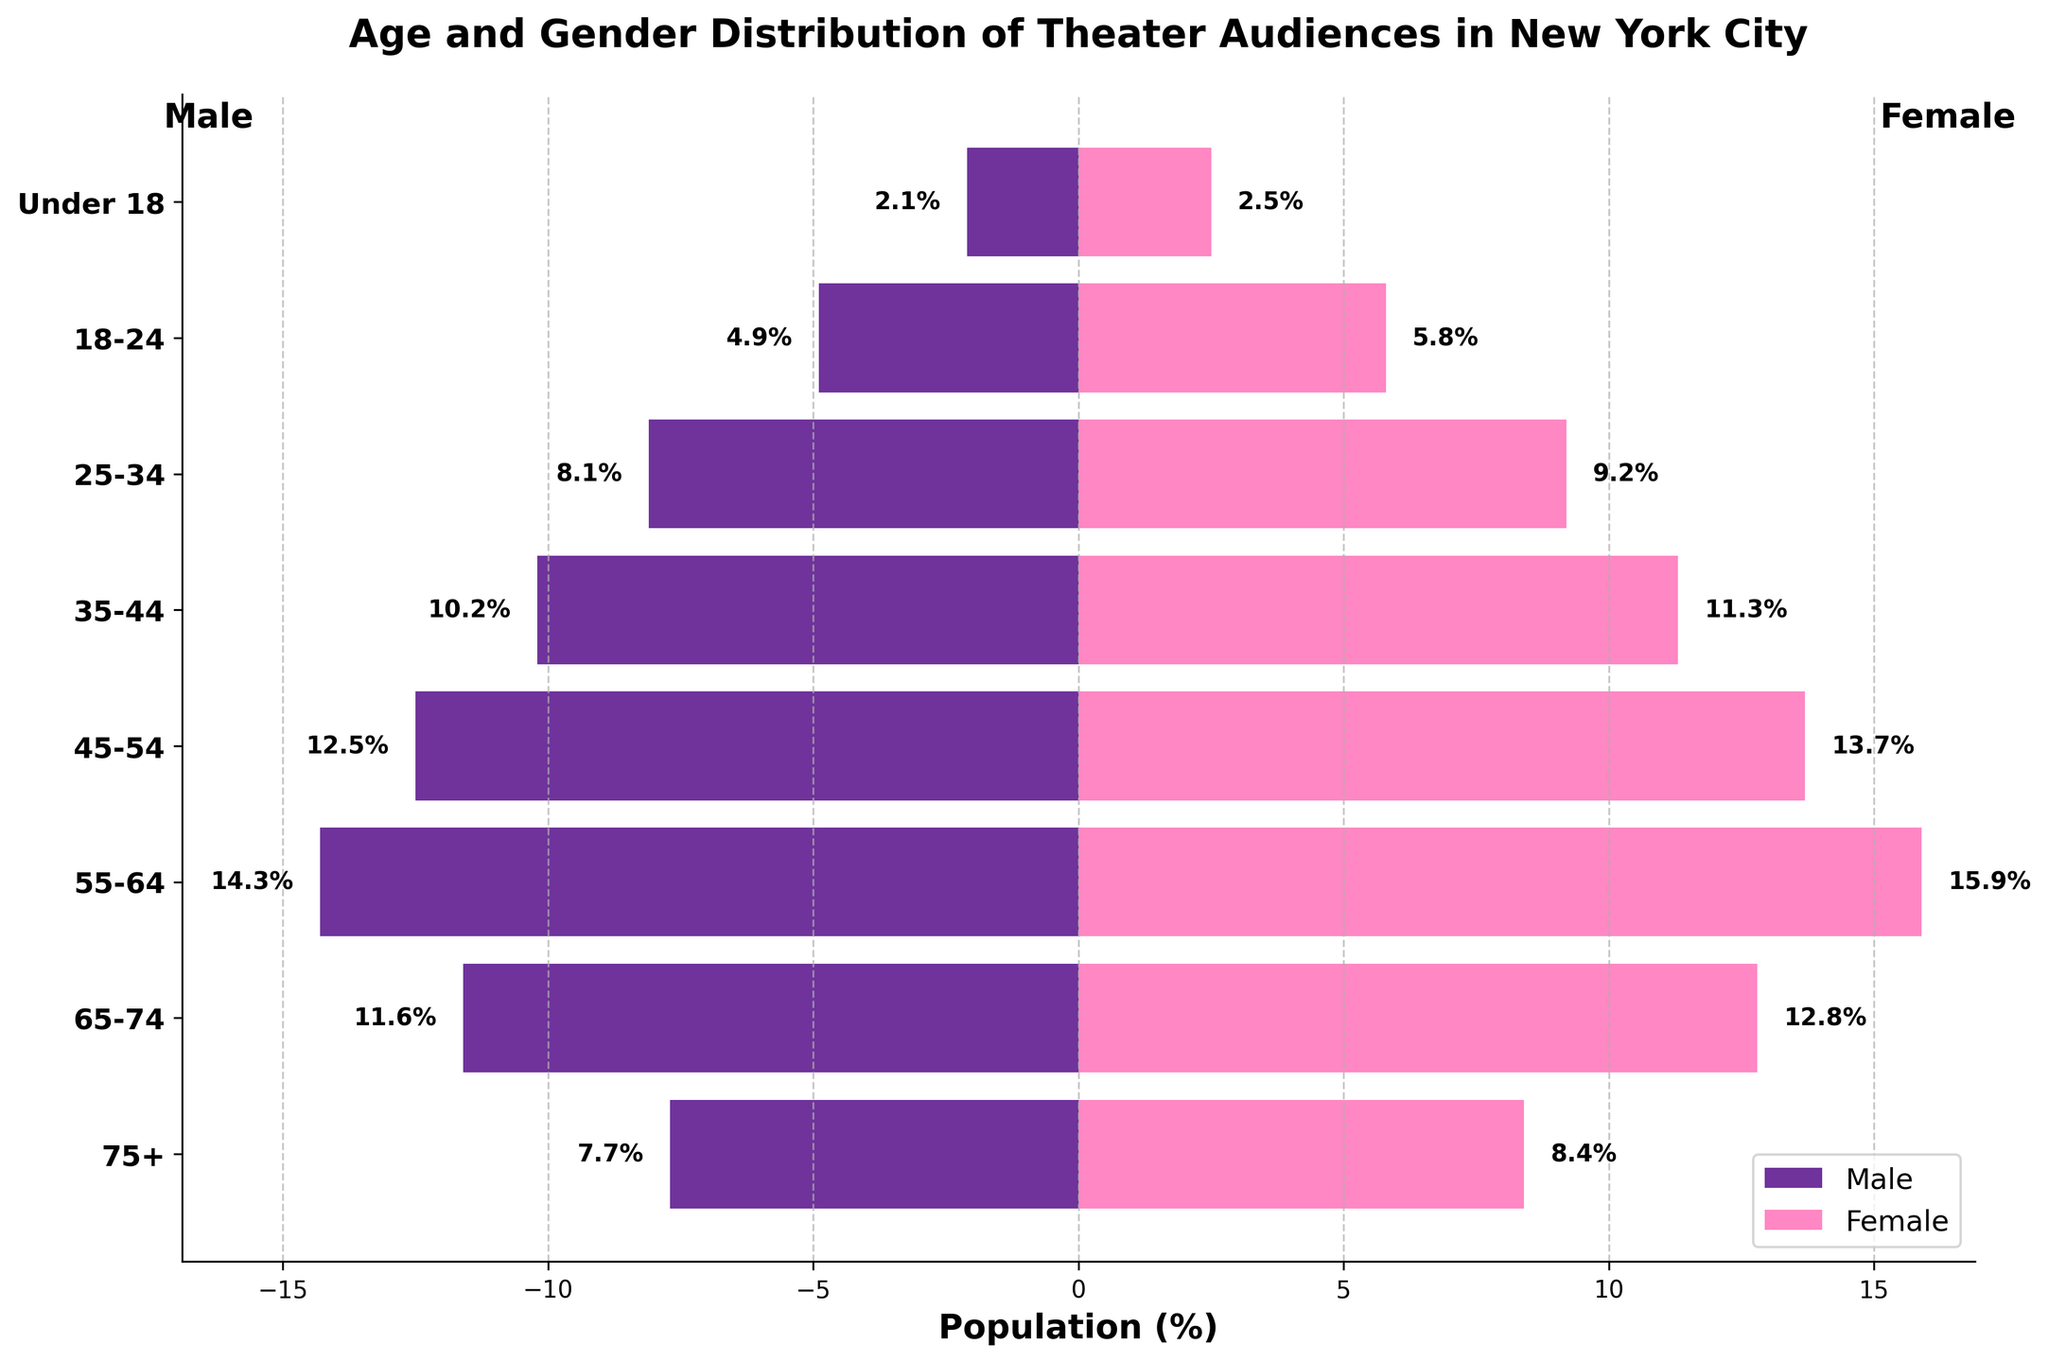Which age group has the highest percentage of female theater audiences? Look at the bar lengths for female audiences to find the longest one, which corresponds to the age group 55-64
Answer: 55-64 What is the total percentage of male theater audiences aged 25-44? Add the percentages of male audiences in the 25-34 and 35-44 age groups (8.1% + 10.2%)
Answer: 18.3% Among the 45-54 age group, which gender has a higher representation? Compare the lengths of the bars for male (12.5%) and female (13.7%) audiences in this age group; the longer bar represents the higher percentage
Answer: Female How does the percentage of female theatergoers aged 65-74 compare to that of males in the same age group? Compare the female (12.8%) and male (-11.6%) percentages in the 65-74 age group; the absolute value of the male percentage is used for comparison
Answer: Female is higher What's the difference in percentage between male and female theatergoers under 18? Subtract the male percentage (2.1%) from the female percentage (2.5%)
Answer: 0.4% Which gender has more even distribution across all age groups? The distributions can be compared by visually assessing variability in bar lengths between male and female segments; male bars appear to have less extreme variation
Answer: Male Which age group sees a nearly equal representation of male and female audiences? Identify age groups where the bars for males and females are almost equal; 25-34 has close percentages: male (8.1%) and female (9.2%)
Answer: 25-34 What is the average percentage of female theater audiences from ages 35-64? Calculate the average from female percentages in the 35-44, 45-54, and 55-64 groups: (11.3 + 13.7 + 15.9) / 3
Answer: 13.63% In which age group is the difference between male and female theatergoers the greatest? Evaluate the differences for each group and find the largest: 55-64 has the largest difference (15.9% - 14.3% = 1.6%)
Answer: 55-64 Is the representation of theater audiences aged 75+ higher in females or males? Compare the bar lengths for the 75+ age group: female (8.4%) vs. male (7.7%)
Answer: Female 